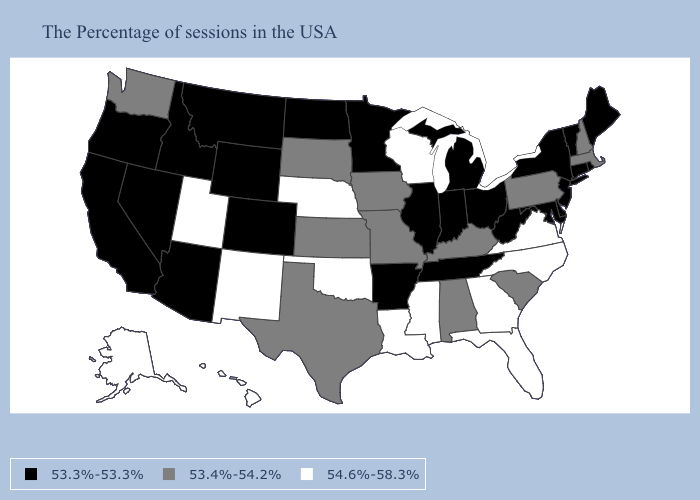What is the value of Montana?
Give a very brief answer. 53.3%-53.3%. Name the states that have a value in the range 54.6%-58.3%?
Keep it brief. Virginia, North Carolina, Florida, Georgia, Wisconsin, Mississippi, Louisiana, Nebraska, Oklahoma, New Mexico, Utah, Alaska, Hawaii. What is the lowest value in states that border Montana?
Concise answer only. 53.3%-53.3%. What is the lowest value in states that border Kansas?
Write a very short answer. 53.3%-53.3%. What is the value of Texas?
Answer briefly. 53.4%-54.2%. Which states have the highest value in the USA?
Concise answer only. Virginia, North Carolina, Florida, Georgia, Wisconsin, Mississippi, Louisiana, Nebraska, Oklahoma, New Mexico, Utah, Alaska, Hawaii. Name the states that have a value in the range 53.3%-53.3%?
Be succinct. Maine, Rhode Island, Vermont, Connecticut, New York, New Jersey, Delaware, Maryland, West Virginia, Ohio, Michigan, Indiana, Tennessee, Illinois, Arkansas, Minnesota, North Dakota, Wyoming, Colorado, Montana, Arizona, Idaho, Nevada, California, Oregon. Name the states that have a value in the range 53.4%-54.2%?
Answer briefly. Massachusetts, New Hampshire, Pennsylvania, South Carolina, Kentucky, Alabama, Missouri, Iowa, Kansas, Texas, South Dakota, Washington. Which states have the lowest value in the West?
Write a very short answer. Wyoming, Colorado, Montana, Arizona, Idaho, Nevada, California, Oregon. What is the lowest value in the South?
Quick response, please. 53.3%-53.3%. Does Connecticut have the lowest value in the USA?
Keep it brief. Yes. What is the value of Kansas?
Answer briefly. 53.4%-54.2%. Which states have the lowest value in the Northeast?
Quick response, please. Maine, Rhode Island, Vermont, Connecticut, New York, New Jersey. Name the states that have a value in the range 54.6%-58.3%?
Answer briefly. Virginia, North Carolina, Florida, Georgia, Wisconsin, Mississippi, Louisiana, Nebraska, Oklahoma, New Mexico, Utah, Alaska, Hawaii. 